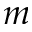<formula> <loc_0><loc_0><loc_500><loc_500>m</formula> 